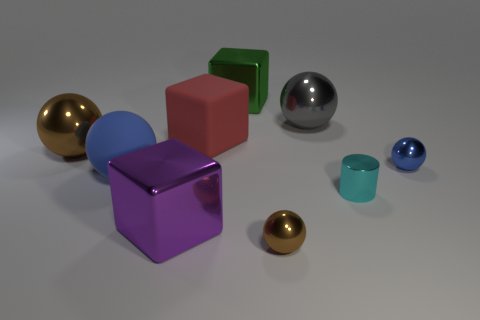What material is the brown thing on the right side of the large ball that is in front of the small blue metal sphere? metal 